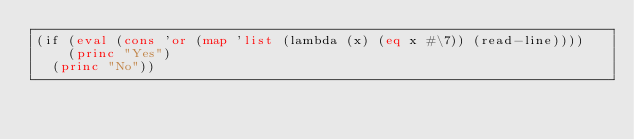<code> <loc_0><loc_0><loc_500><loc_500><_Lisp_>(if (eval (cons 'or (map 'list (lambda (x) (eq x #\7)) (read-line))))
    (princ "Yes")
  (princ "No"))
</code> 